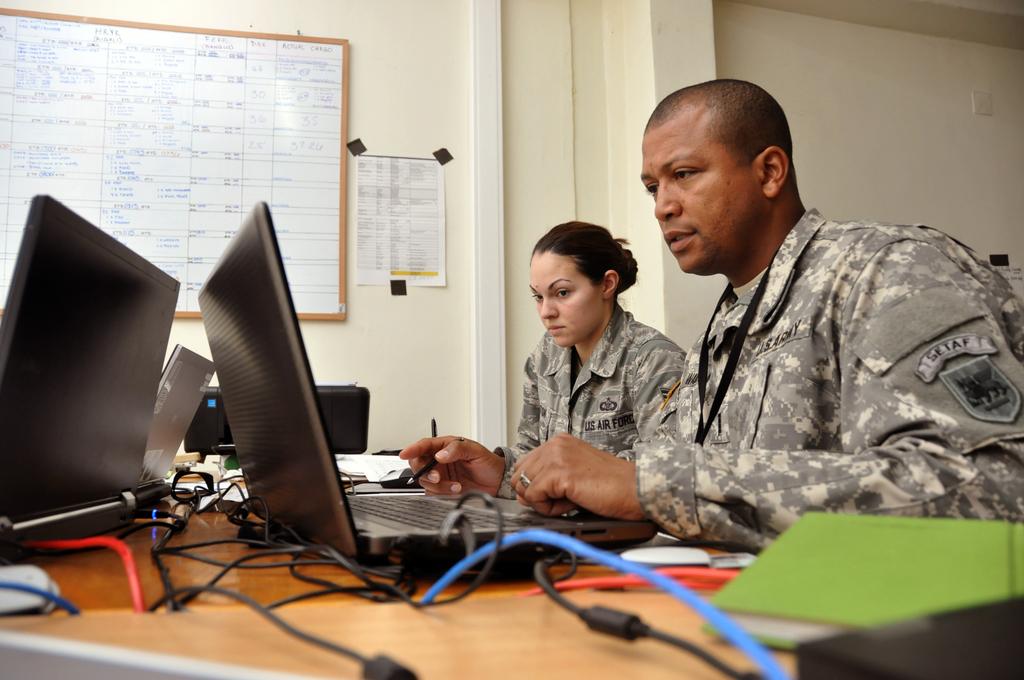Is the man on the right from the air force or the army?
Keep it short and to the point. Army. What is written on the woman's front side of jacket?
Offer a very short reply. Us air force. 